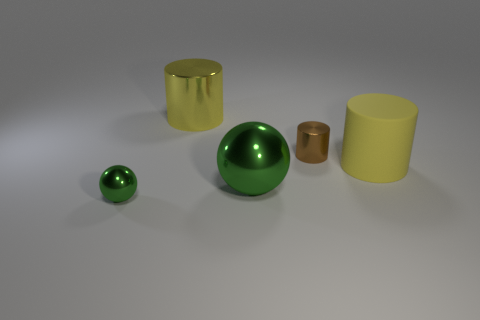Subtract all tiny brown cylinders. How many cylinders are left? 2 Subtract all blue balls. How many yellow cylinders are left? 2 Add 4 brown objects. How many objects exist? 9 Subtract 1 cylinders. How many cylinders are left? 2 Subtract all brown cylinders. How many cylinders are left? 2 Subtract all cylinders. How many objects are left? 2 Subtract all big cyan rubber blocks. Subtract all yellow objects. How many objects are left? 3 Add 4 small metal objects. How many small metal objects are left? 6 Add 3 metal cylinders. How many metal cylinders exist? 5 Subtract 0 brown spheres. How many objects are left? 5 